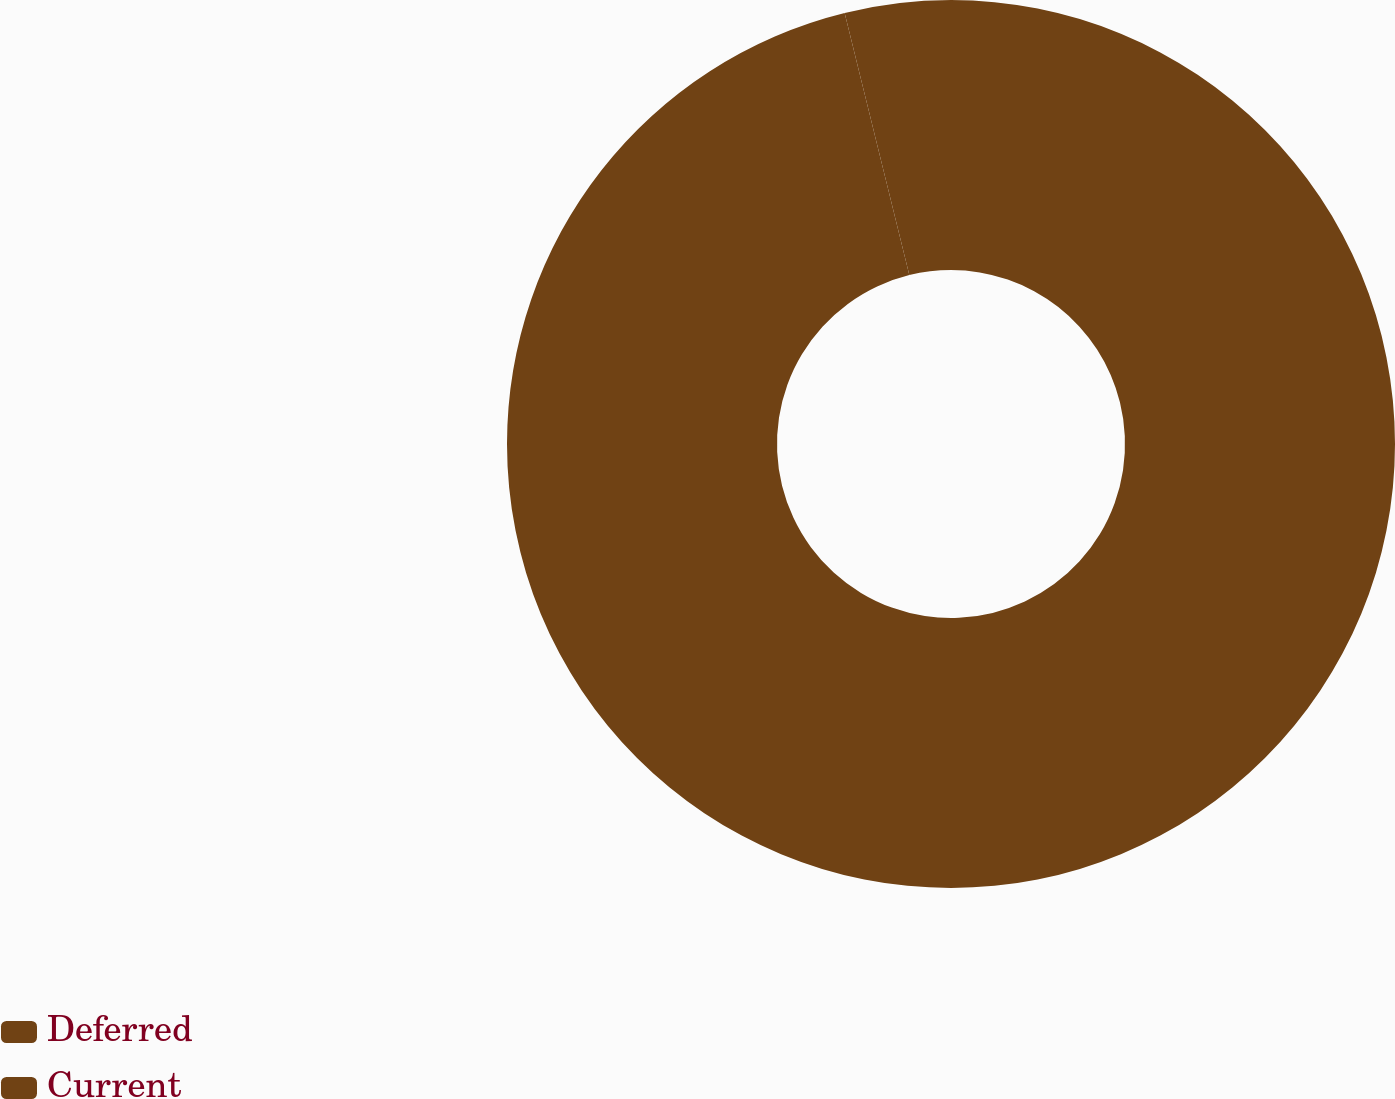Convert chart. <chart><loc_0><loc_0><loc_500><loc_500><pie_chart><fcel>Deferred<fcel>Current<nl><fcel>96.15%<fcel>3.85%<nl></chart> 